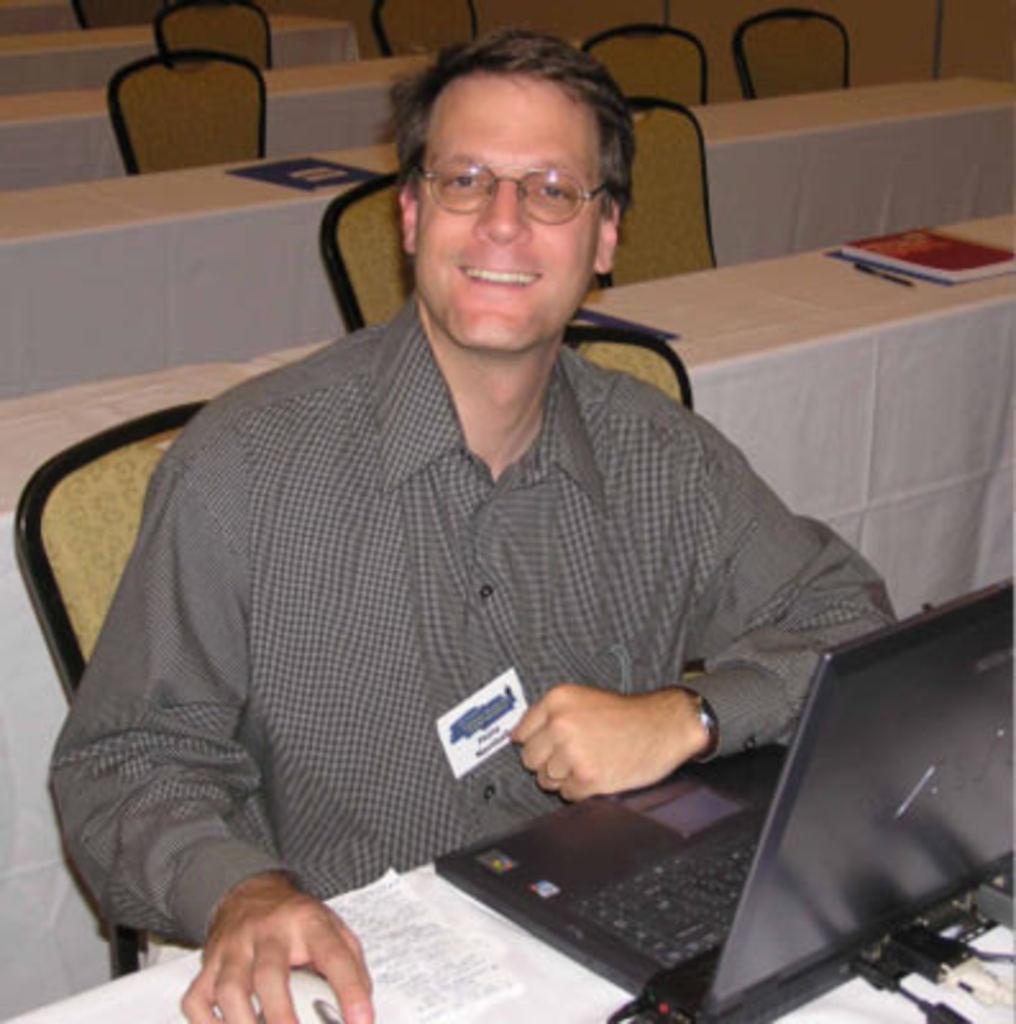Can you describe this image briefly? In this image we can see a man sitting on the chair and holding a paper in his hand. We can see laptop and book placed on the table in front of the man. In the background we can see books, chairs and tables. 